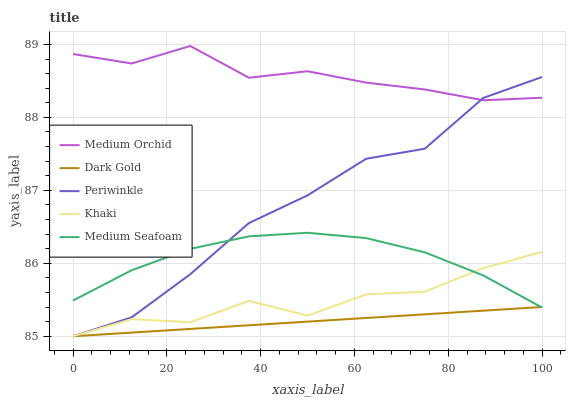Does Dark Gold have the minimum area under the curve?
Answer yes or no. Yes. Does Medium Orchid have the maximum area under the curve?
Answer yes or no. Yes. Does Periwinkle have the minimum area under the curve?
Answer yes or no. No. Does Periwinkle have the maximum area under the curve?
Answer yes or no. No. Is Dark Gold the smoothest?
Answer yes or no. Yes. Is Khaki the roughest?
Answer yes or no. Yes. Is Medium Orchid the smoothest?
Answer yes or no. No. Is Medium Orchid the roughest?
Answer yes or no. No. Does Periwinkle have the lowest value?
Answer yes or no. Yes. Does Medium Orchid have the lowest value?
Answer yes or no. No. Does Medium Orchid have the highest value?
Answer yes or no. Yes. Does Periwinkle have the highest value?
Answer yes or no. No. Is Medium Seafoam less than Medium Orchid?
Answer yes or no. Yes. Is Medium Orchid greater than Khaki?
Answer yes or no. Yes. Does Dark Gold intersect Periwinkle?
Answer yes or no. Yes. Is Dark Gold less than Periwinkle?
Answer yes or no. No. Is Dark Gold greater than Periwinkle?
Answer yes or no. No. Does Medium Seafoam intersect Medium Orchid?
Answer yes or no. No. 